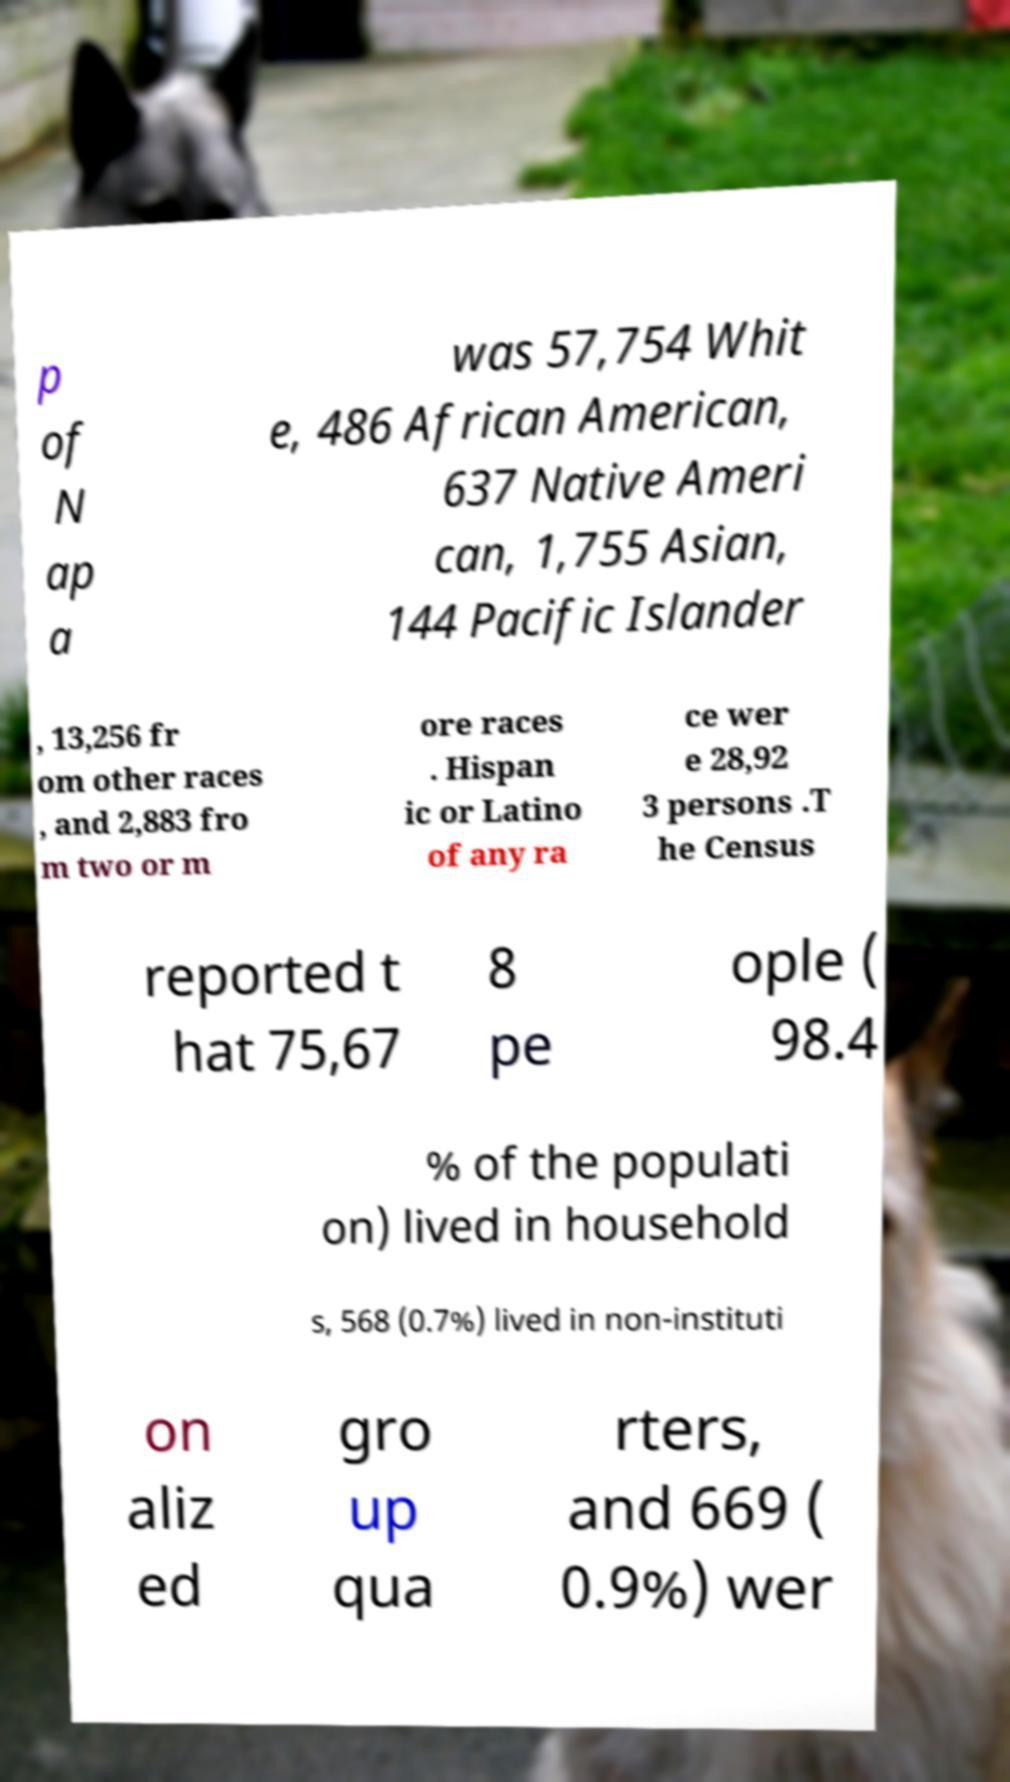Can you read and provide the text displayed in the image?This photo seems to have some interesting text. Can you extract and type it out for me? p of N ap a was 57,754 Whit e, 486 African American, 637 Native Ameri can, 1,755 Asian, 144 Pacific Islander , 13,256 fr om other races , and 2,883 fro m two or m ore races . Hispan ic or Latino of any ra ce wer e 28,92 3 persons .T he Census reported t hat 75,67 8 pe ople ( 98.4 % of the populati on) lived in household s, 568 (0.7%) lived in non-instituti on aliz ed gro up qua rters, and 669 ( 0.9%) wer 